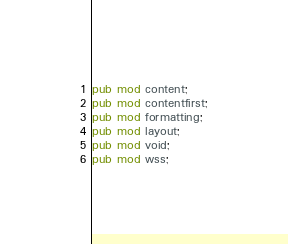<code> <loc_0><loc_0><loc_500><loc_500><_Rust_>pub mod content;
pub mod contentfirst;
pub mod formatting;
pub mod layout;
pub mod void;
pub mod wss;
</code> 